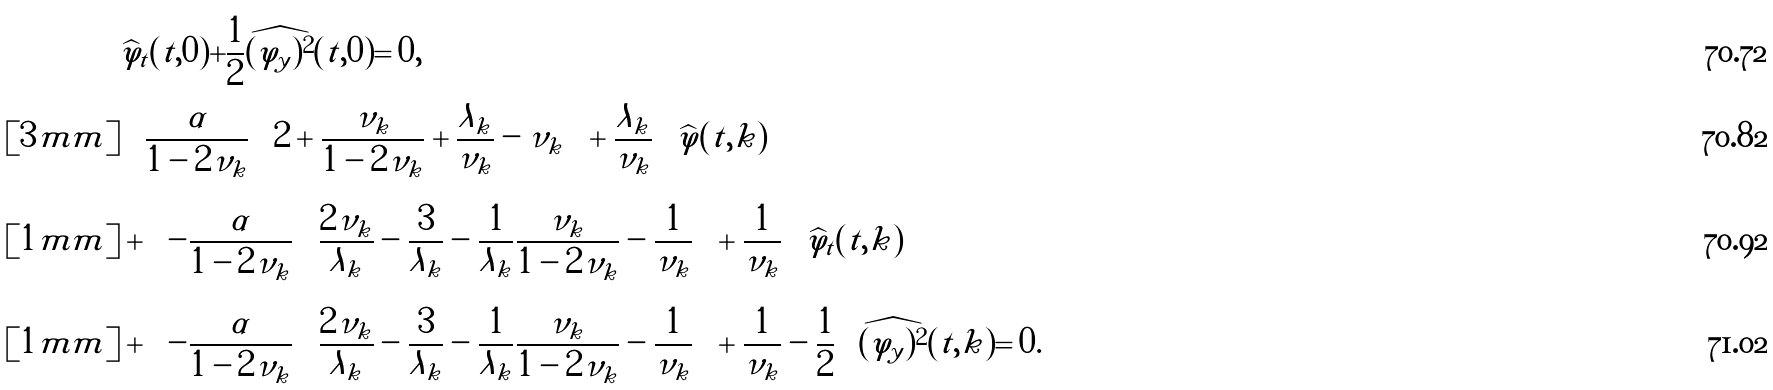Convert formula to latex. <formula><loc_0><loc_0><loc_500><loc_500>& \widehat { \varphi } _ { t } ( t , 0 ) + \frac { 1 } { 2 } \widehat { ( \varphi _ { y } ) ^ { 2 } } ( t , 0 ) = 0 , \\ [ 3 m m ] & \left \{ \frac { \alpha } { 1 - 2 \nu _ { k } } \left ( 2 + \frac { \nu _ { k } } { 1 - 2 \nu _ { k } } + \frac { \lambda _ { k } } { \nu _ { k } } - \nu _ { k } \right ) + \frac { \lambda _ { k } } { \nu _ { k } } \right \} \widehat { \varphi } ( t , k ) \\ [ 1 m m ] & + \left \{ - \frac { \alpha } { 1 - 2 \nu _ { k } } \left ( \frac { 2 \nu _ { k } } { \lambda _ { k } } - \frac { 3 } { \lambda _ { k } } - \frac { 1 } { \lambda _ { k } } \frac { \nu _ { k } } { 1 - 2 \nu _ { k } } - \frac { 1 } { \nu _ { k } } \right ) + \frac { 1 } { \nu _ { k } } \right \} \widehat { \varphi } _ { t } ( t , k ) \\ [ 1 m m ] & + \left \{ - \frac { \alpha } { 1 - 2 \nu _ { k } } \left ( \frac { 2 \nu _ { k } } { \lambda _ { k } } - \frac { 3 } { \lambda _ { k } } - \frac { 1 } { \lambda _ { k } } \frac { \nu _ { k } } { 1 - 2 \nu _ { k } } - \frac { 1 } { \nu _ { k } } \right ) + \frac { 1 } { \nu _ { k } } - \frac { 1 } { 2 } \right \} \widehat { ( \varphi _ { y } ) ^ { 2 } } ( t , k ) = 0 .</formula> 